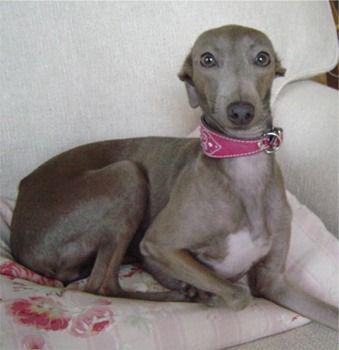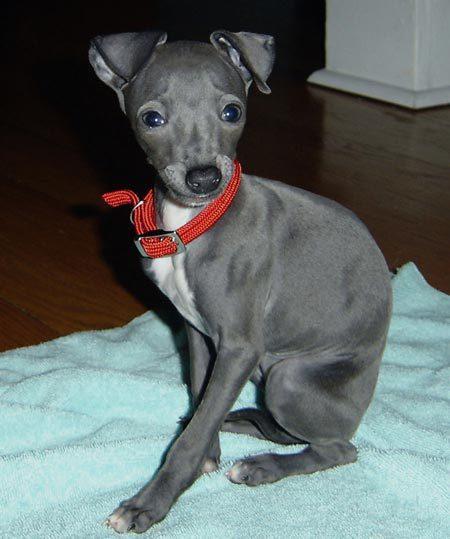The first image is the image on the left, the second image is the image on the right. For the images displayed, is the sentence "One image shows a light brown dog standing." factually correct? Answer yes or no. No. 